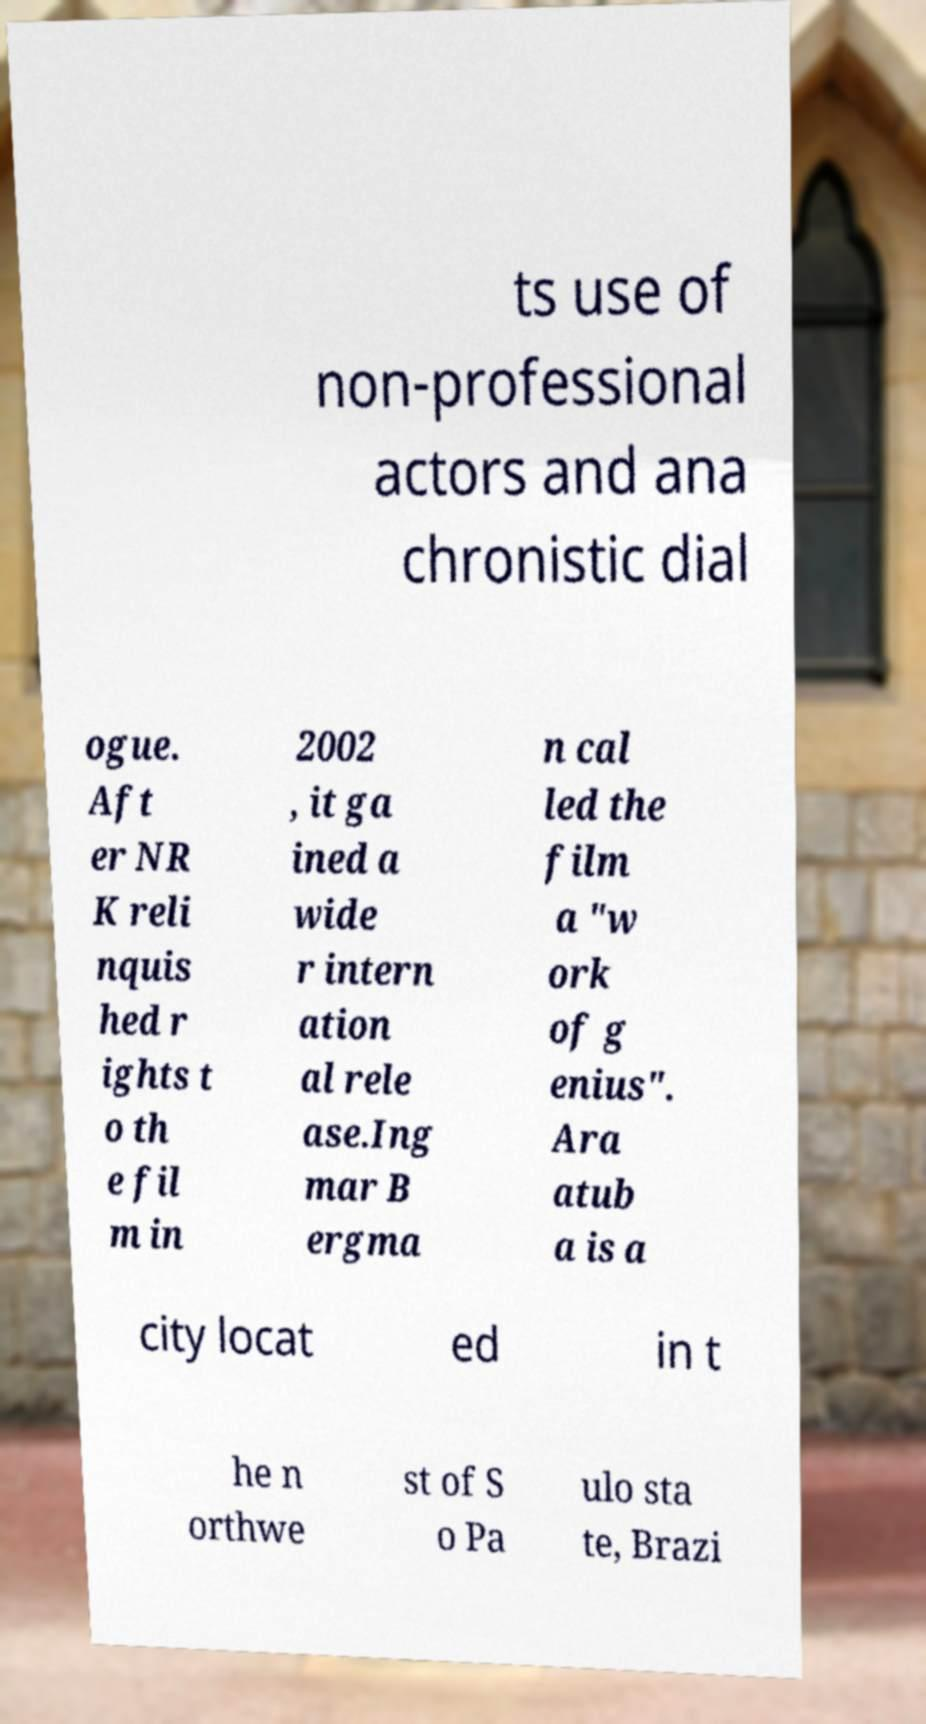Can you read and provide the text displayed in the image?This photo seems to have some interesting text. Can you extract and type it out for me? ts use of non-professional actors and ana chronistic dial ogue. Aft er NR K reli nquis hed r ights t o th e fil m in 2002 , it ga ined a wide r intern ation al rele ase.Ing mar B ergma n cal led the film a "w ork of g enius". Ara atub a is a city locat ed in t he n orthwe st of S o Pa ulo sta te, Brazi 